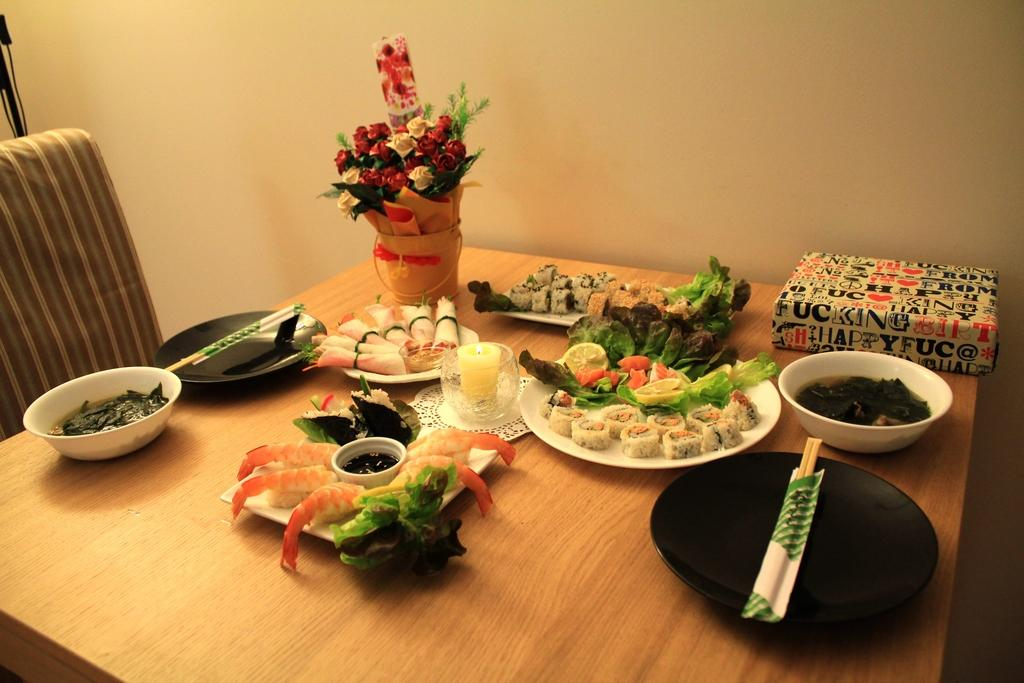What type of furniture is present in the image? There is a chair and a table in the image. What is on top of the table? There is a lot of food, a box, and flowers on the table. What can be seen in the background of the image? There is a wall in the background of the image. What type of twig is used as a centerpiece on the table? There is no twig present on the table in the image. 